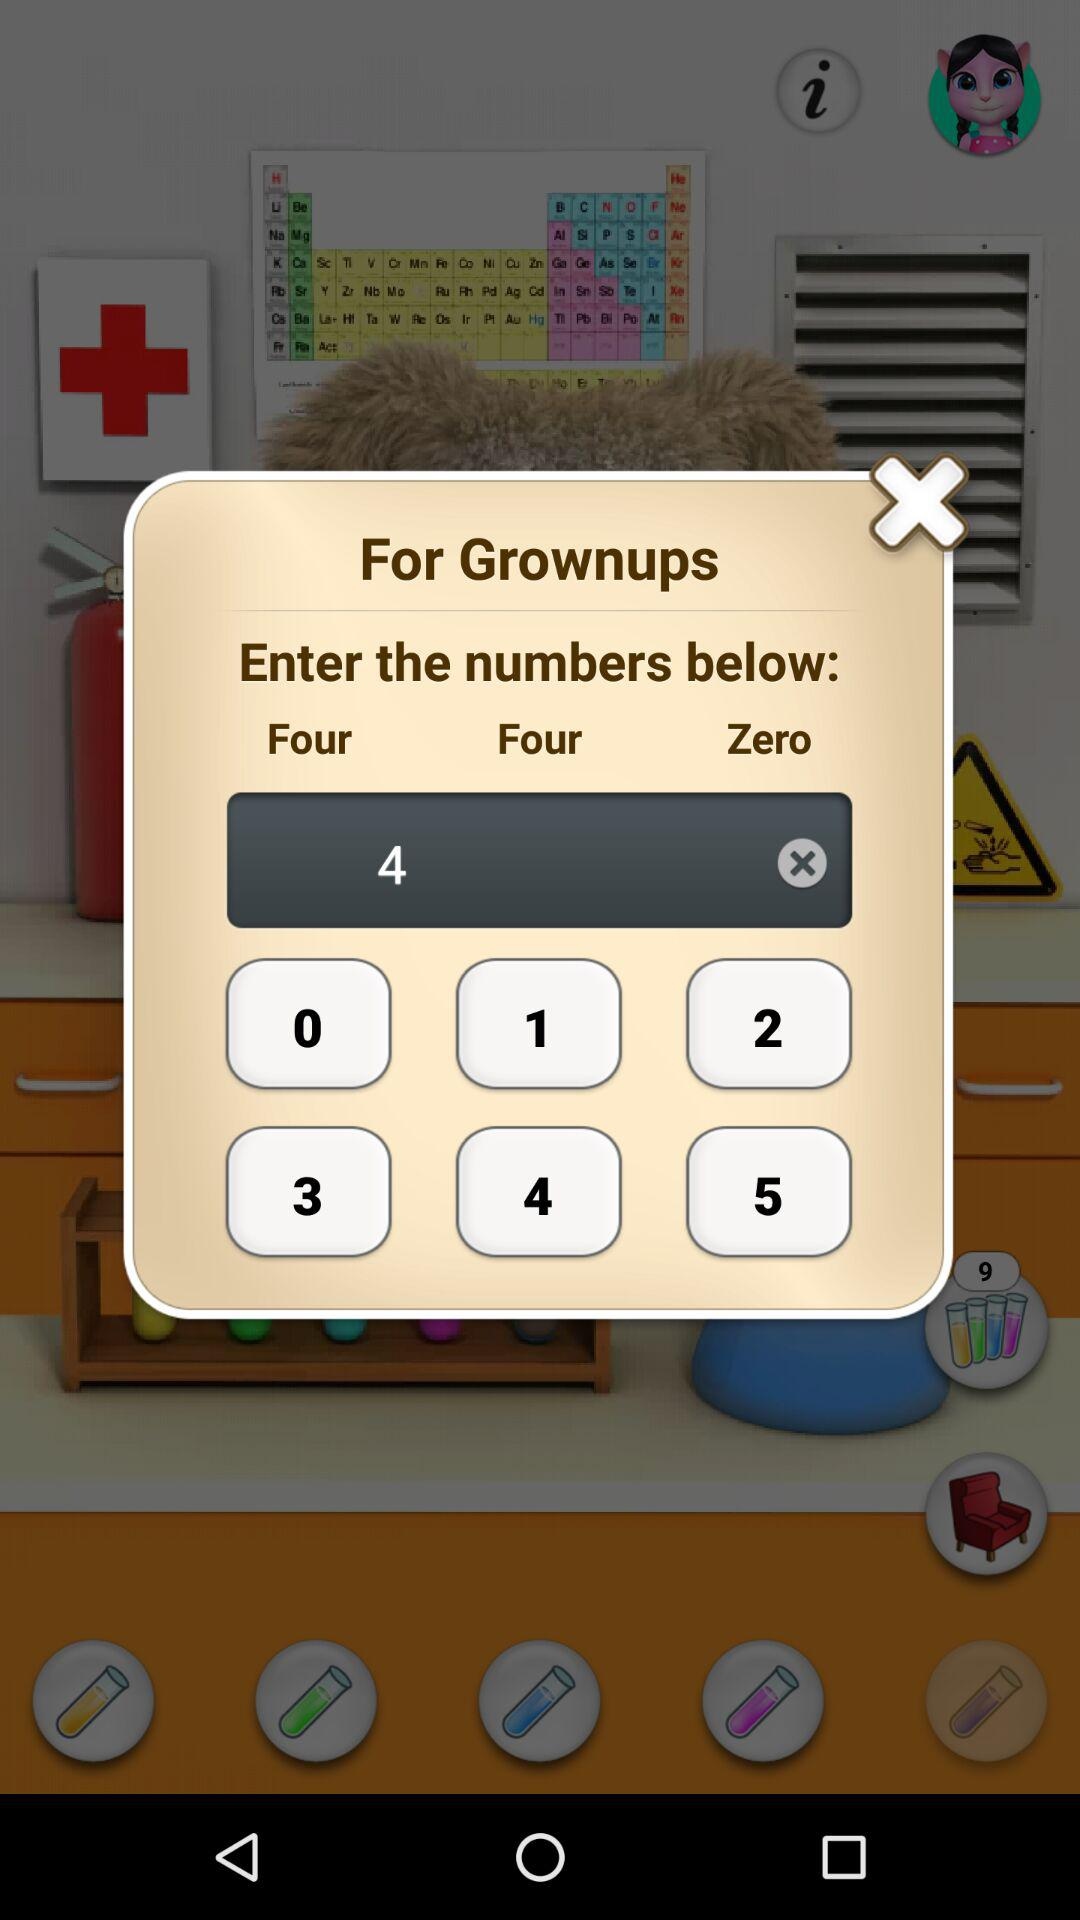What is the mentioned number for "Enter the numbers below:"? The mentioned numbers for "Enter the numbers below:" are "Four", "Four" and "Zero". 